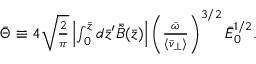<formula> <loc_0><loc_0><loc_500><loc_500>\begin{array} { r } { \bar { \Theta } \equiv 4 \sqrt { \frac { 2 } { \pi } } \left | \int _ { 0 } ^ { \bar { z } } d \bar { z } ^ { \prime } \bar { \tilde { B } } ( \bar { z } ) \right | \left ( \frac { \bar { \omega } } { \langle \bar { v } _ { \perp } \rangle } \right ) ^ { 3 / 2 } \bar { E } _ { 0 } ^ { 1 / 2 } . } \end{array}</formula> 